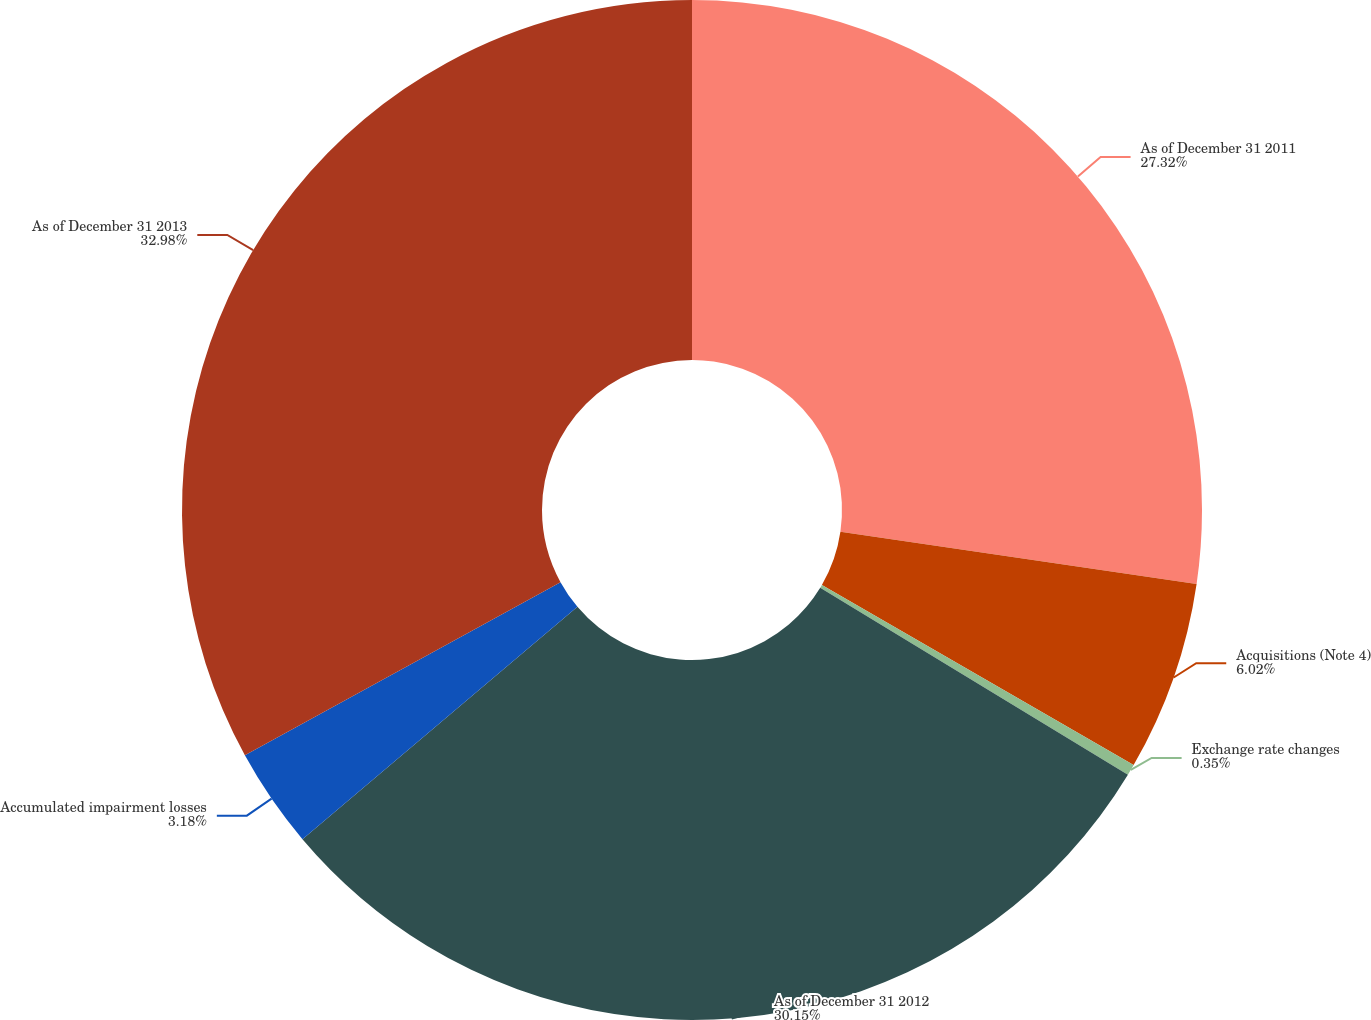Convert chart. <chart><loc_0><loc_0><loc_500><loc_500><pie_chart><fcel>As of December 31 2011<fcel>Acquisitions (Note 4)<fcel>Exchange rate changes<fcel>As of December 31 2012<fcel>Accumulated impairment losses<fcel>As of December 31 2013<nl><fcel>27.32%<fcel>6.02%<fcel>0.35%<fcel>30.15%<fcel>3.18%<fcel>32.99%<nl></chart> 